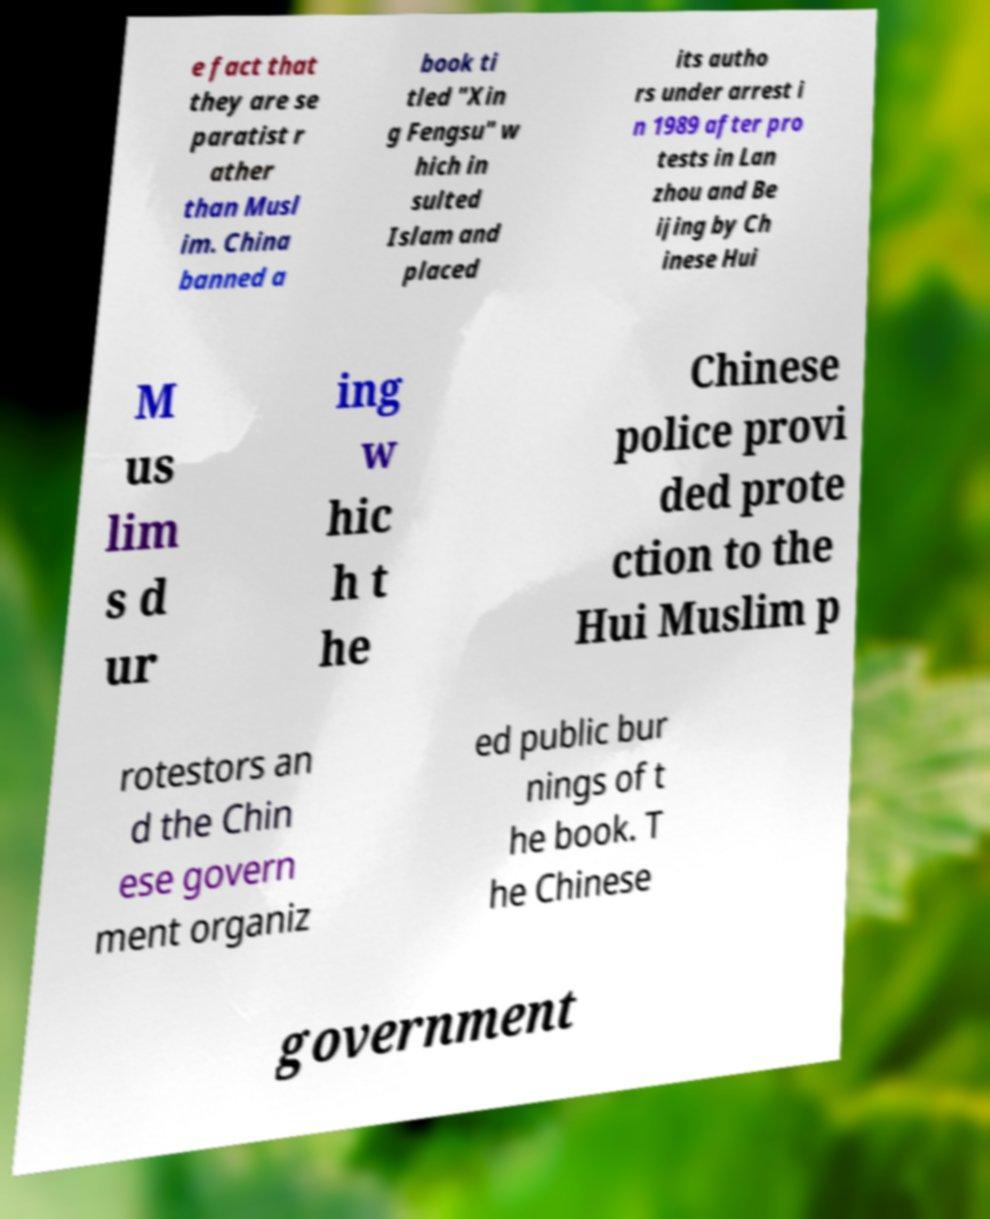I need the written content from this picture converted into text. Can you do that? e fact that they are se paratist r ather than Musl im. China banned a book ti tled "Xin g Fengsu" w hich in sulted Islam and placed its autho rs under arrest i n 1989 after pro tests in Lan zhou and Be ijing by Ch inese Hui M us lim s d ur ing w hic h t he Chinese police provi ded prote ction to the Hui Muslim p rotestors an d the Chin ese govern ment organiz ed public bur nings of t he book. T he Chinese government 